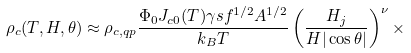Convert formula to latex. <formula><loc_0><loc_0><loc_500><loc_500>\rho _ { c } ( T , H , \theta ) \approx \rho _ { c , q p } \frac { \Phi _ { 0 } J _ { c 0 } ( T ) \gamma s f ^ { 1 / 2 } A ^ { 1 / 2 } } { k _ { B } T } \left ( \frac { H _ { j } } { H | \cos \theta | } \right ) ^ { \nu } \times</formula> 